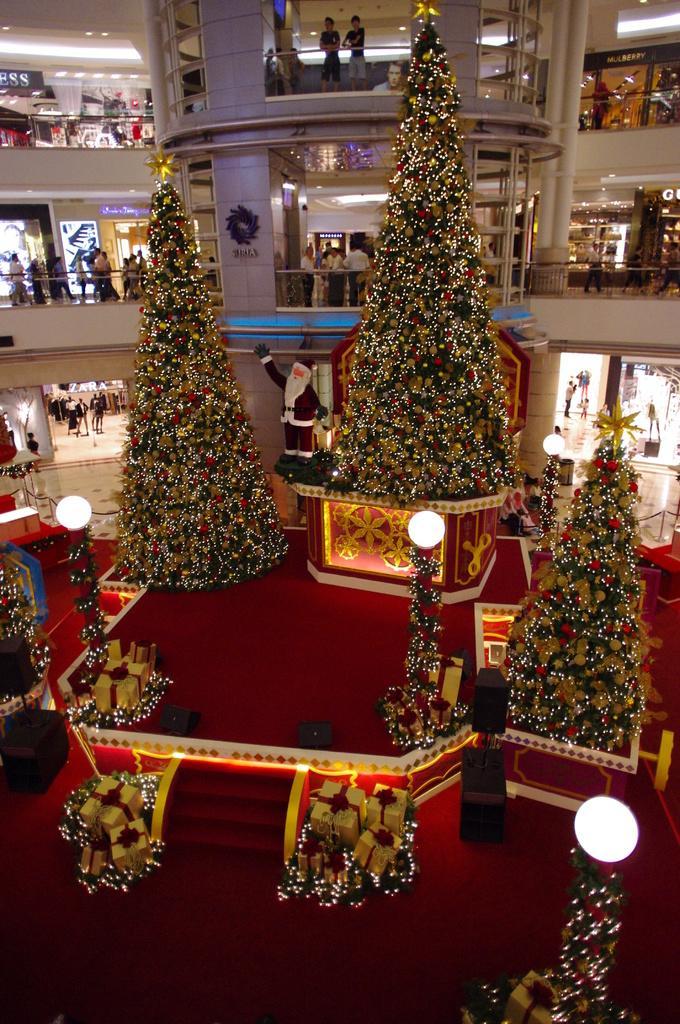Could you give a brief overview of what you see in this image? In this image, in the right side, we can see a Christmas tree with light. On the right side, we can see a Christmas tree and a few lights. On the left side, we can also see the Christmas tree. In the middle of the image, we can see some gift boxes, staircase. In the background, we can see a Christmas tree and a building, in the buildings, we can see a group of people, few people are walking and few people are standing, metal rod, pillars. At the top, we can see a sky, at the bottom, we can see a red color carpet and a floor. 